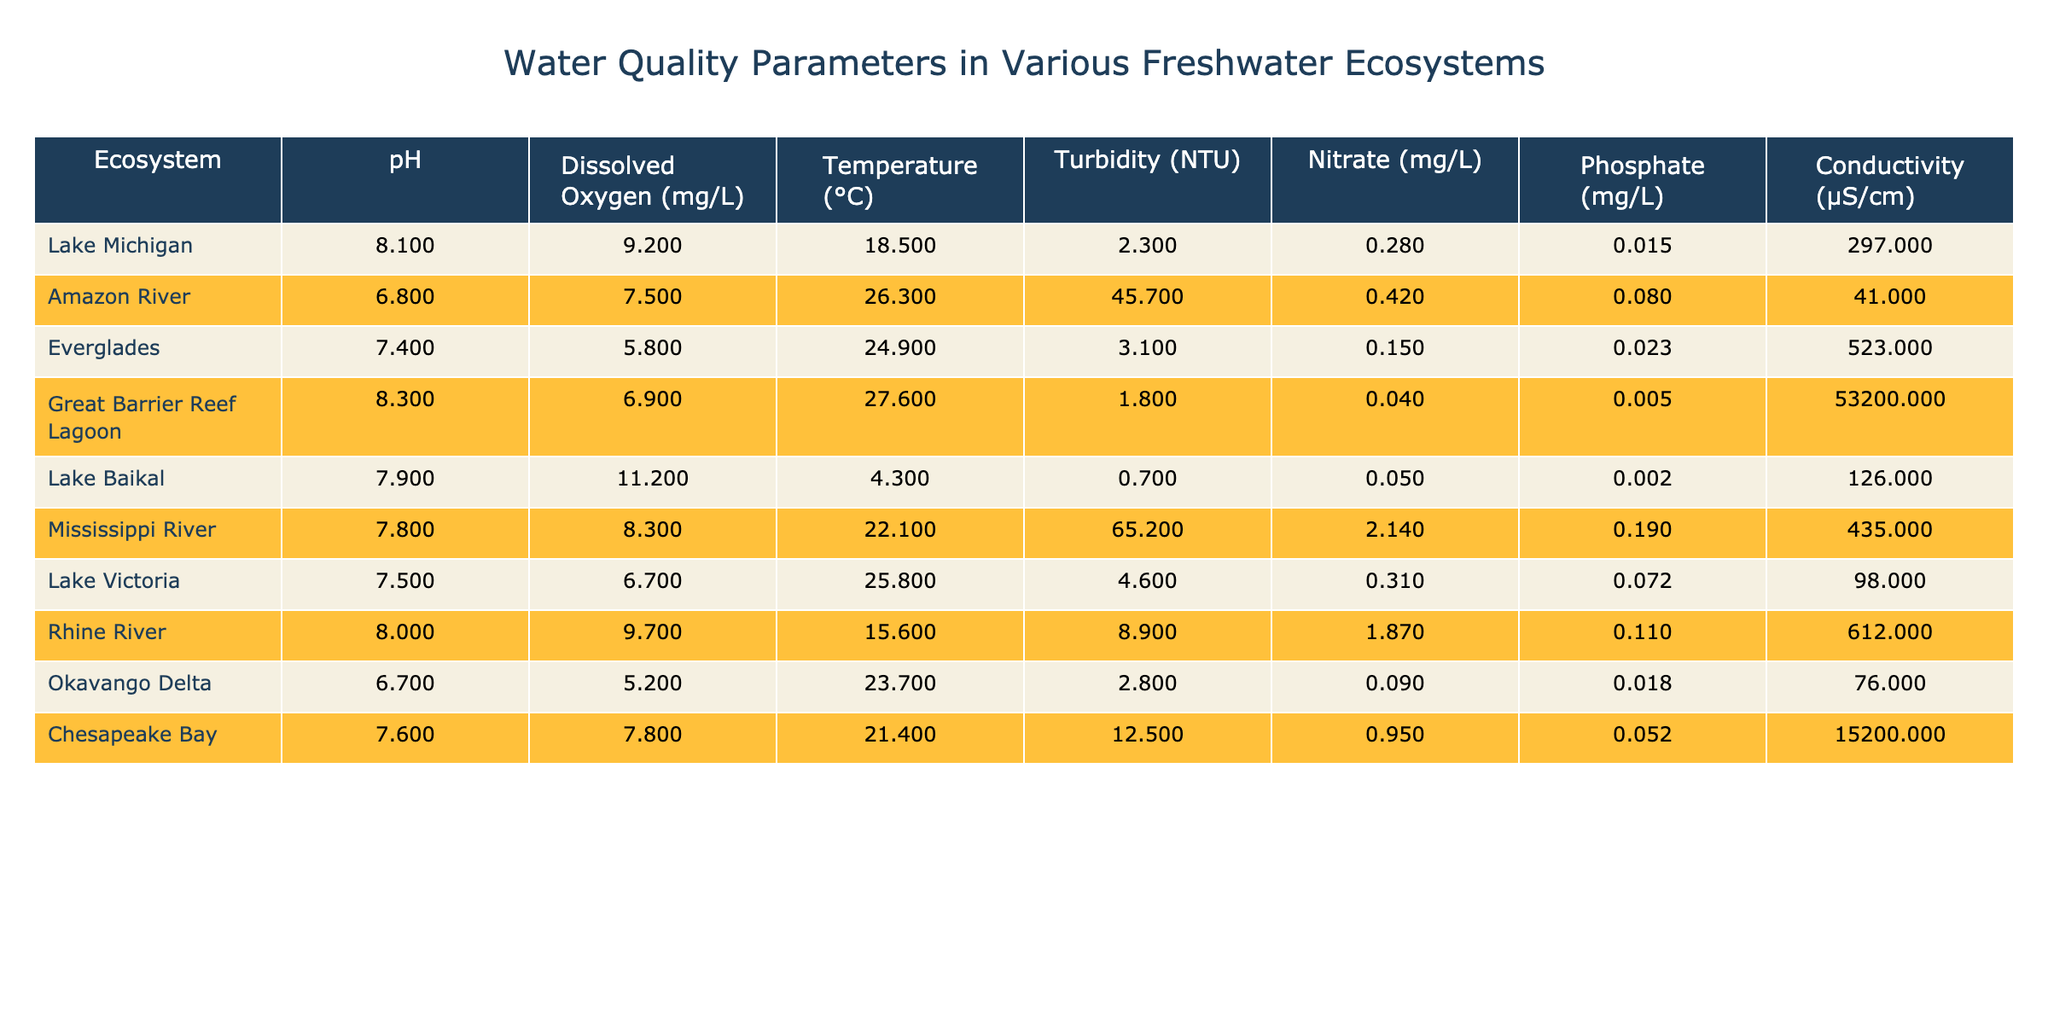What is the pH level of the Amazon River? The pH level column for the Amazon River states a value of 6.8.
Answer: 6.8 Which ecosystem has the highest turbidity value? By looking at the turbidity column, the Mississippi River has the highest value at 65.2 NTU.
Answer: Mississippi River What is the average dissolved oxygen level across all the ecosystems? The dissolved oxygen levels are 9.2, 7.5, 5.8, 6.9, 11.2, 8.3, 6.7, 9.7, 5.2, and 7.8. Summing these gives 69.3, and dividing by 10 results in an average of 6.93 mg/L.
Answer: 6.93 mg/L Is the conductivity level of Lake Michigan higher than that of Lake Baikal? Lake Michigan's conductivity is 297 µS/cm, and Lake Baikal's is 126 µS/cm. Since 297 is greater than 126, the statement is true.
Answer: Yes What is the difference in pH levels between the Great Barrier Reef Lagoon and the Okavango Delta? The pH of the Great Barrier Reef Lagoon is 8.3, and that of the Okavango Delta is 6.7. Thus, the difference is 8.3 - 6.7 = 1.6.
Answer: 1.6 Which ecosystem has the lowest nitrate concentration, and what is that value? Examining the nitrate column, the Great Barrier Reef Lagoon has a concentration of 0.04 mg/L, which is the lowest value.
Answer: Great Barrier Reef Lagoon, 0.04 mg/L Who has a higher average temperature: ecosystems from regions with pH lower than 7 or those with pH higher than 7? The ecosystems with pH lower than 7 (Amazon River, Everglades, Okavango Delta) have temperatures 26.3, 24.9, and 23.7 °C, yielding an average of (26.3 + 24.9 + 23.7) / 3 = 24.63 °C. For those above 7 (Lake Michigan, Great Barrier Reef Lagoon, Lake Baikal, Mississippi River, Lake Victoria, Rhine River, Chesapeake Bay), the temperatures are 18.5, 27.6, 4.3, 22.1, 25.8, 15.6, and 21.4 °C, giving an average of (18.5 + 27.6 + 4.3 + 22.1 + 25.8 + 15.6 + 21.4) / 7 = 18.60 °C. Comparing 24.63 °C and 18.60 °C, the first average is higher.
Answer: Ecosystems with pH lower than 7 are higher Which ecosystem has the highest concentration of phosphate? Observing the phosphate column, the Amazon River has the highest phosphate concentration at 0.08 mg/L.
Answer: Amazon River, 0.08 mg/L What is the total turbidity of the ecosystems in the table? Summing the turbidity values: 2.3 + 45.7 + 3.1 + 1.8 + 0.7 + 65.2 + 4.6 + 8.9 + 2.8 + 12.5 gives a total of 143.6 NTU.
Answer: 143.6 NTU Are there any ecosystems with a dissolved oxygen level below 6 mg/L? Checking the dissolved oxygen levels, the Everglades and Okavango Delta have levels of 5.8 and 5.2 mg/L, respectively, both below 6. Thus, the statement is true.
Answer: Yes 